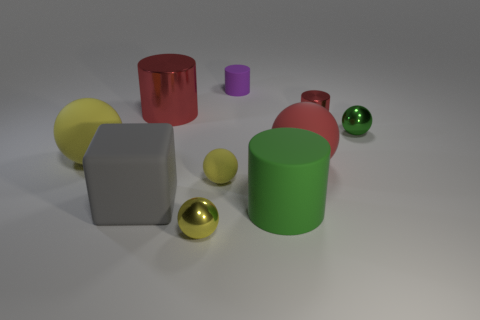Subtract all yellow cylinders. How many yellow balls are left? 3 Subtract all red spheres. How many spheres are left? 4 Subtract all tiny yellow matte spheres. How many spheres are left? 4 Subtract all blue cylinders. Subtract all brown blocks. How many cylinders are left? 4 Subtract all cubes. How many objects are left? 9 Add 8 red rubber spheres. How many red rubber spheres exist? 9 Subtract 1 red balls. How many objects are left? 9 Subtract all tiny red objects. Subtract all large metallic objects. How many objects are left? 8 Add 5 matte spheres. How many matte spheres are left? 8 